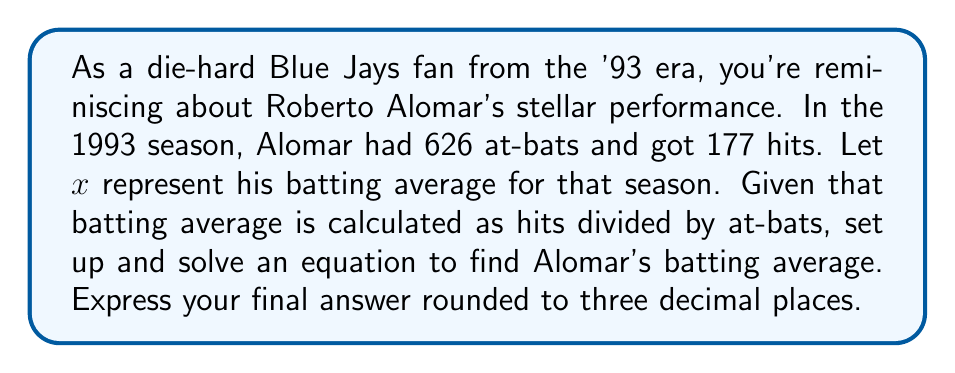Can you answer this question? Let's approach this step-by-step:

1) First, recall the formula for batting average:
   $$ \text{Batting Average} = \frac{\text{Number of Hits}}{\text{Number of At-Bats}} $$

2) We're given:
   - Number of Hits = 177
   - Number of At-Bats = 626
   - Let $x$ represent the batting average

3) Substituting these into our equation:
   $$ x = \frac{177}{626} $$

4) To solve this, we simply need to divide 177 by 626:
   $$ x = 0.28274760383... $$

5) Rounding to three decimal places as requested:
   $$ x \approx 0.283 $$

This means Roberto Alomar's batting average for the 1993 season was approximately 0.283 or .283 in baseball notation.
Answer: $0.283$ 